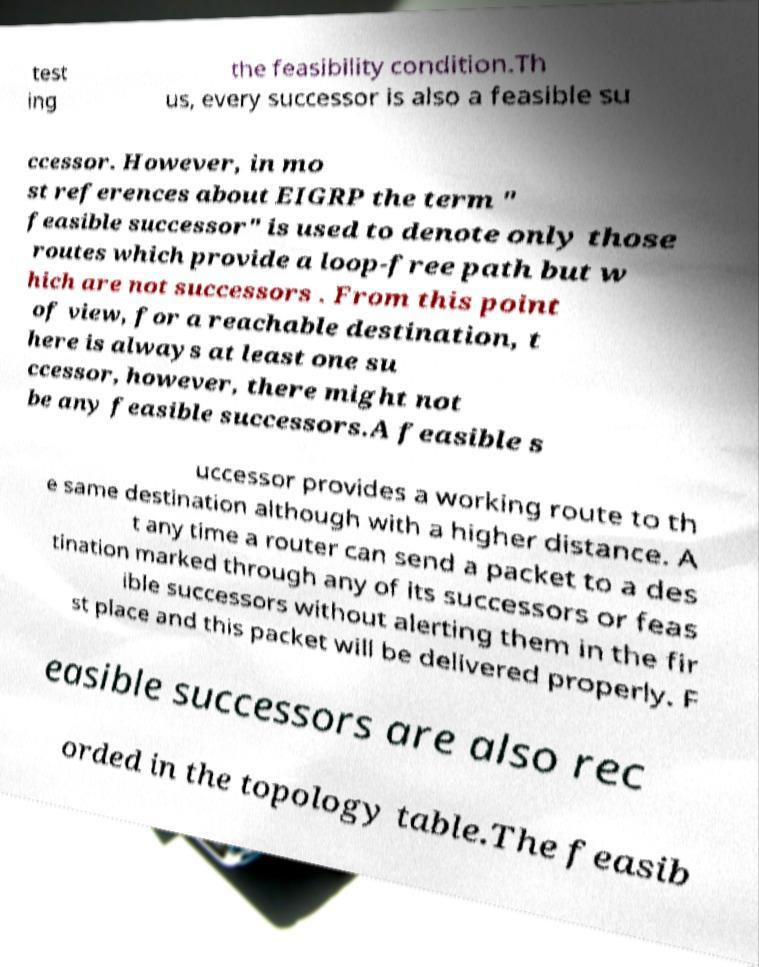Can you read and provide the text displayed in the image?This photo seems to have some interesting text. Can you extract and type it out for me? test ing the feasibility condition.Th us, every successor is also a feasible su ccessor. However, in mo st references about EIGRP the term " feasible successor" is used to denote only those routes which provide a loop-free path but w hich are not successors . From this point of view, for a reachable destination, t here is always at least one su ccessor, however, there might not be any feasible successors.A feasible s uccessor provides a working route to th e same destination although with a higher distance. A t any time a router can send a packet to a des tination marked through any of its successors or feas ible successors without alerting them in the fir st place and this packet will be delivered properly. F easible successors are also rec orded in the topology table.The feasib 